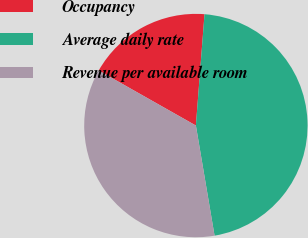Convert chart to OTSL. <chart><loc_0><loc_0><loc_500><loc_500><pie_chart><fcel>Occupancy<fcel>Average daily rate<fcel>Revenue per available room<nl><fcel>18.03%<fcel>46.09%<fcel>35.87%<nl></chart> 